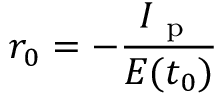<formula> <loc_0><loc_0><loc_500><loc_500>r _ { 0 } = - \frac { I _ { p } } { E ( t _ { 0 } ) }</formula> 